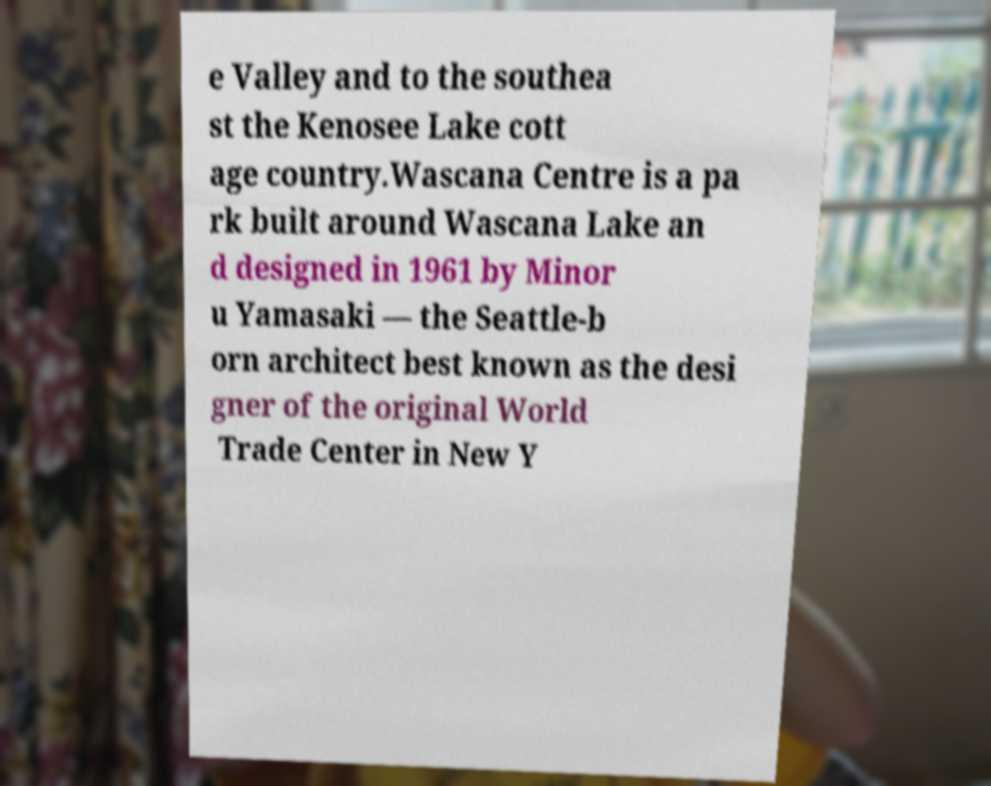Please read and relay the text visible in this image. What does it say? e Valley and to the southea st the Kenosee Lake cott age country.Wascana Centre is a pa rk built around Wascana Lake an d designed in 1961 by Minor u Yamasaki — the Seattle-b orn architect best known as the desi gner of the original World Trade Center in New Y 